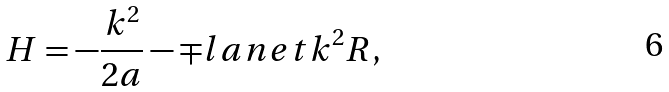<formula> <loc_0><loc_0><loc_500><loc_500>H = - \frac { k ^ { 2 } } { 2 a } - \mp l a n e t k ^ { 2 } R ,</formula> 